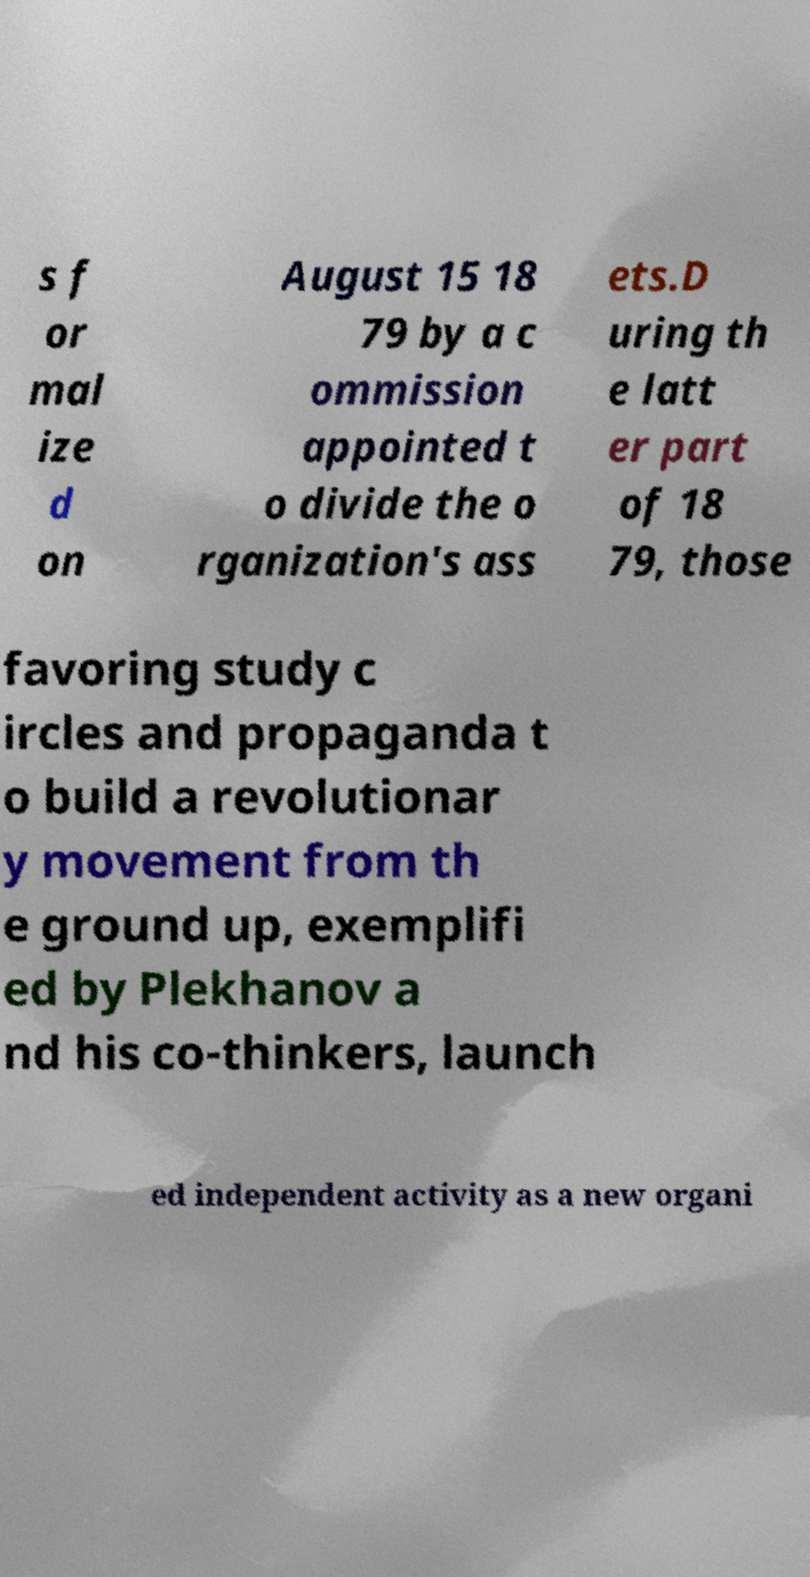There's text embedded in this image that I need extracted. Can you transcribe it verbatim? s f or mal ize d on August 15 18 79 by a c ommission appointed t o divide the o rganization's ass ets.D uring th e latt er part of 18 79, those favoring study c ircles and propaganda t o build a revolutionar y movement from th e ground up, exemplifi ed by Plekhanov a nd his co-thinkers, launch ed independent activity as a new organi 